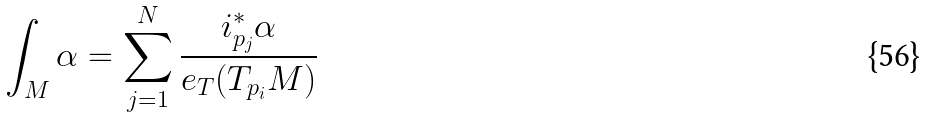Convert formula to latex. <formula><loc_0><loc_0><loc_500><loc_500>\int _ { M } \alpha = \sum _ { j = 1 } ^ { N } \frac { i _ { p _ { j } } ^ { * } \alpha } { e _ { T } ( T _ { p _ { i } } M ) }</formula> 